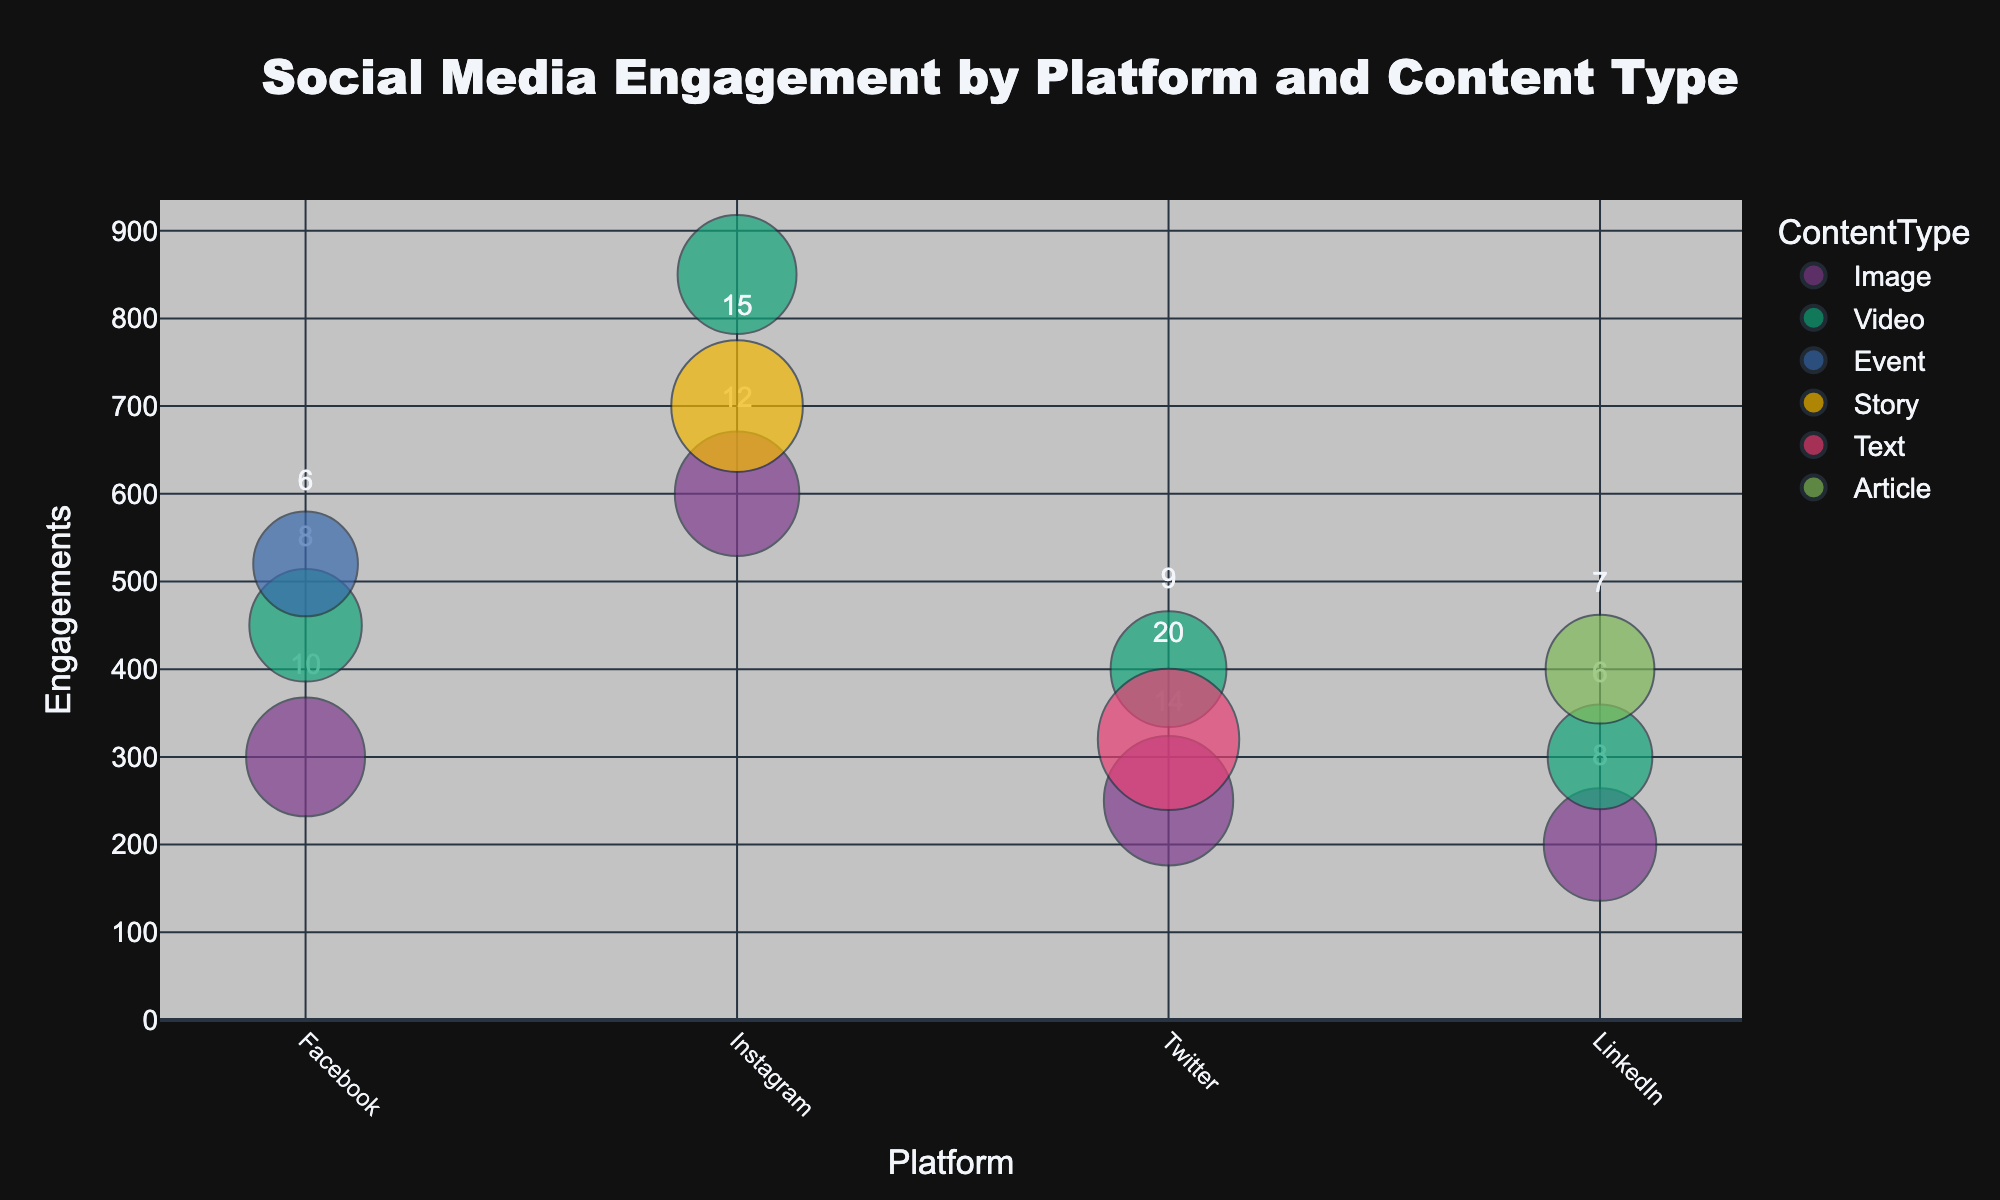What is the title of the chart? The title is prominently displayed at the top center of the chart and reads "Social Media Engagement by Platform and Content Type."
Answer: Social Media Engagement by Platform and Content Type What are the axes labels on the chart? The x-axis is labeled "Platform," and the y-axis is labeled "Engagements," as indicated by the text below and beside the respective axes.
Answer: Platform, Engagements Which platform has the most engagements for image content? Looking at the bubble positions on the y-axis, Instagram has the highest engagements of 600 for image content.
Answer: Instagram Which content type has the highest engagements on Facebook? By finding the highest bubble on the y-axis for Facebook, the Event content type has the most engagements at 520.
Answer: Event What is the size of the bubble representing Video content on Twitter? The bubble size is proportional to the number of posts. The Video bubble on Twitter has "9" written inside it, and its area corresponds to a size factor derived from the number of posts.
Answer: 9 Which platform has the most diverse content types displayed? By counting the different colors (content types) per platform, Instagram has three content types: Image, Video, and Story.
Answer: Instagram How does the number of posts for Image content on LinkedIn compare to Instagram? LinkedIn's Image content has 8 posts, while Instagram's Image content has 12 posts. Therefore, Instagram has more posts.
Answer: Instagram has more posts What is the average number of engagements for Video content across all platforms? Calculating the average involves (450 + 850 + 400 + 300) engagements for Facebook, Instagram, Twitter, and LinkedIn respectively, divided by 4 platforms: (450 + 850 + 400 + 300) / 4 = 2000 / 4.
Answer: 500 Which platform and content type combination has the smallest bubble? The smallest bubbles are determined by visual inspection of the bubble sizes; the smallest appears to be LinkedIn Image with 8 posts.
Answer: LinkedIn Image 